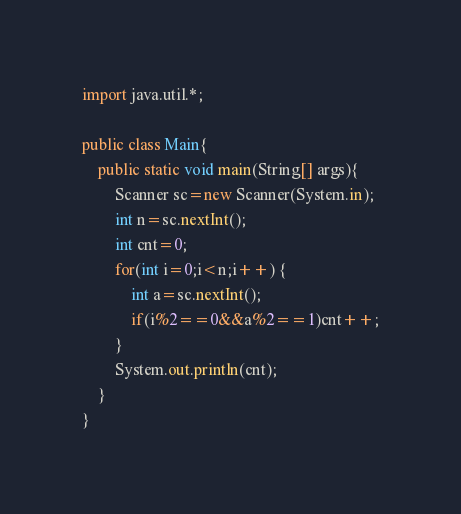<code> <loc_0><loc_0><loc_500><loc_500><_Java_>import java.util.*;

public class Main{
	public static void main(String[] args){
		Scanner sc=new Scanner(System.in);
		int n=sc.nextInt();
		int cnt=0;
		for(int i=0;i<n;i++) {
			int a=sc.nextInt();
			if(i%2==0&&a%2==1)cnt++;
		}
		System.out.println(cnt);
	}
}</code> 